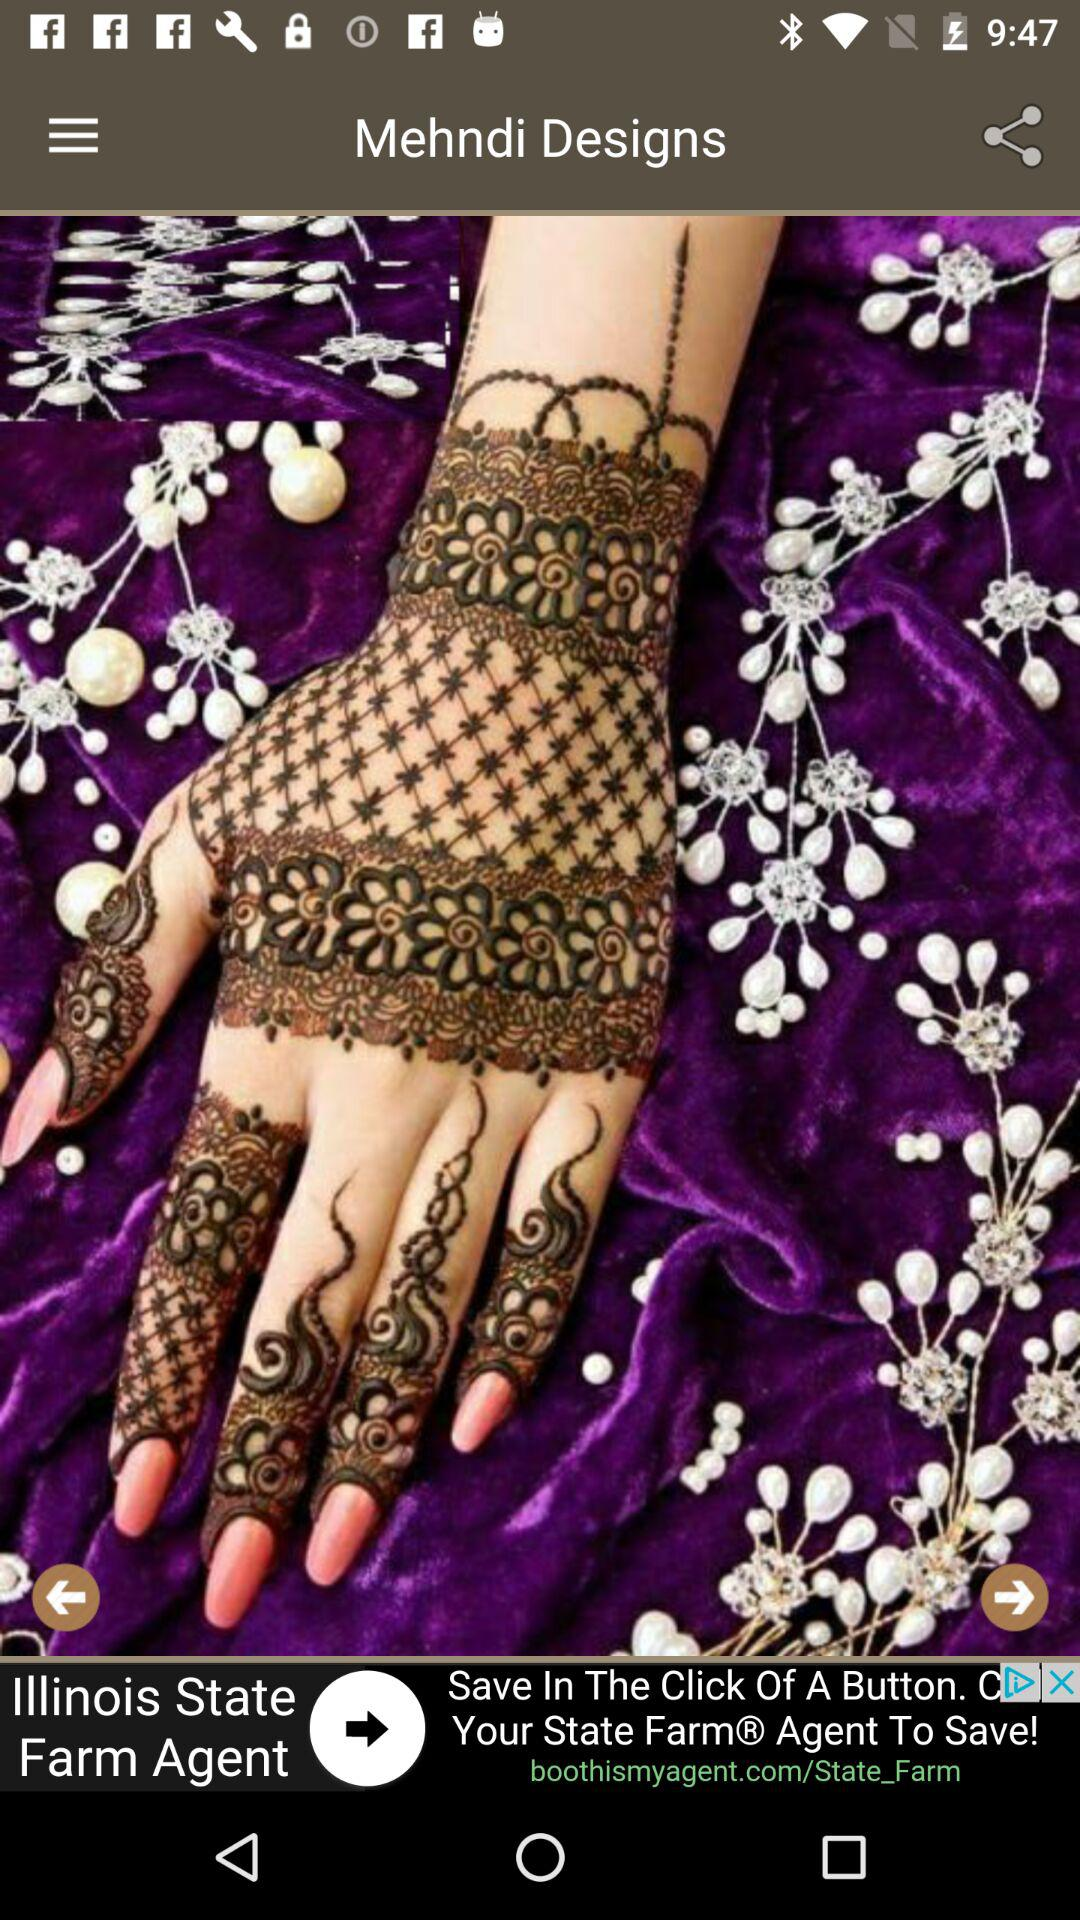What is the application name? The application name is "Mehndi Designs". 